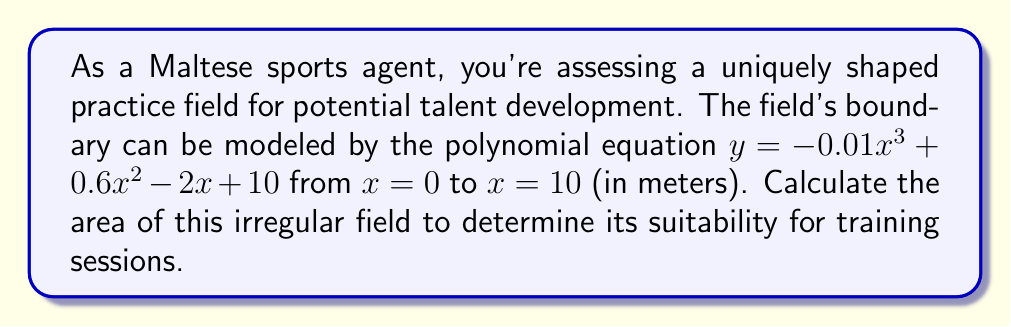Give your solution to this math problem. To calculate the area of this irregularly shaped field, we need to use definite integration. The steps are as follows:

1) The area under a curve from $a$ to $b$ is given by the definite integral:

   $$ A = \int_{a}^{b} f(x) dx $$

2) In this case, $f(x) = -0.01x^3 + 0.6x^2 - 2x + 10$, $a = 0$, and $b = 10$

3) Let's integrate the function:

   $$ \int (-0.01x^3 + 0.6x^2 - 2x + 10) dx $$
   $$ = -0.0025x^4 + 0.2x^3 - x^2 + 10x + C $$

4) Now, we apply the limits:

   $$ A = [-0.0025x^4 + 0.2x^3 - x^2 + 10x]_0^{10} $$

5) Substitute $x = 10$:

   $$ -0.0025(10000) + 0.2(1000) - 100 + 100 = -25 + 200 - 100 + 100 = 175 $$

6) Subtract the value at $x = 0$ (which is 0):

   $$ 175 - 0 = 175 $$

Therefore, the area of the field is 175 square meters.
Answer: 175 m² 